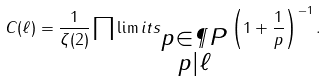Convert formula to latex. <formula><loc_0><loc_0><loc_500><loc_500>C ( \ell ) = \frac { 1 } { \zeta ( 2 ) } \prod \lim i t s _ { \substack { p \in \P P \\ p | \ell } } \left ( 1 + \frac { 1 } { p } \right ) ^ { - 1 } .</formula> 